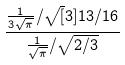<formula> <loc_0><loc_0><loc_500><loc_500>\frac { \frac { 1 } { 3 \sqrt { \pi } } / \sqrt { [ } 3 ] { 1 3 / 1 6 } } { \frac { 1 } { \sqrt { \pi } } / \sqrt { 2 / 3 } }</formula> 